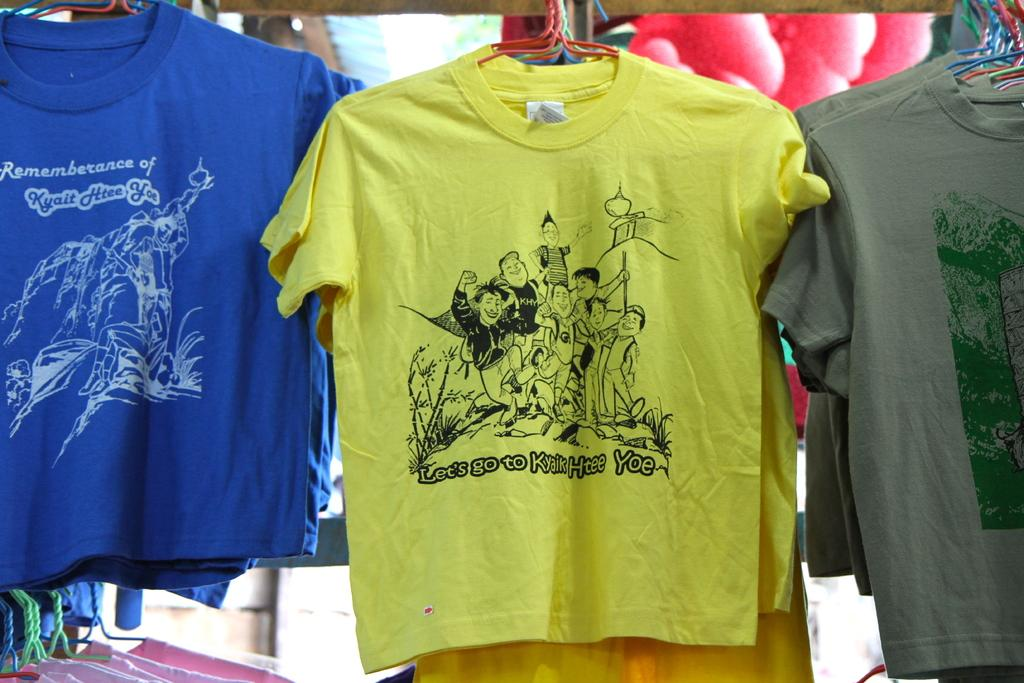What type of clothing item is visible in the image? There is a t-shirt in the image. What is used to hang the t-shirt in the image? There are hangers in the image. Can you describe the background of the image? There are objects in the background of the image. What type of toy can be seen on the tramp in the image? There is no tramp or toy present in the image. What invention is being demonstrated in the image? There is no invention being demonstrated in the image. 